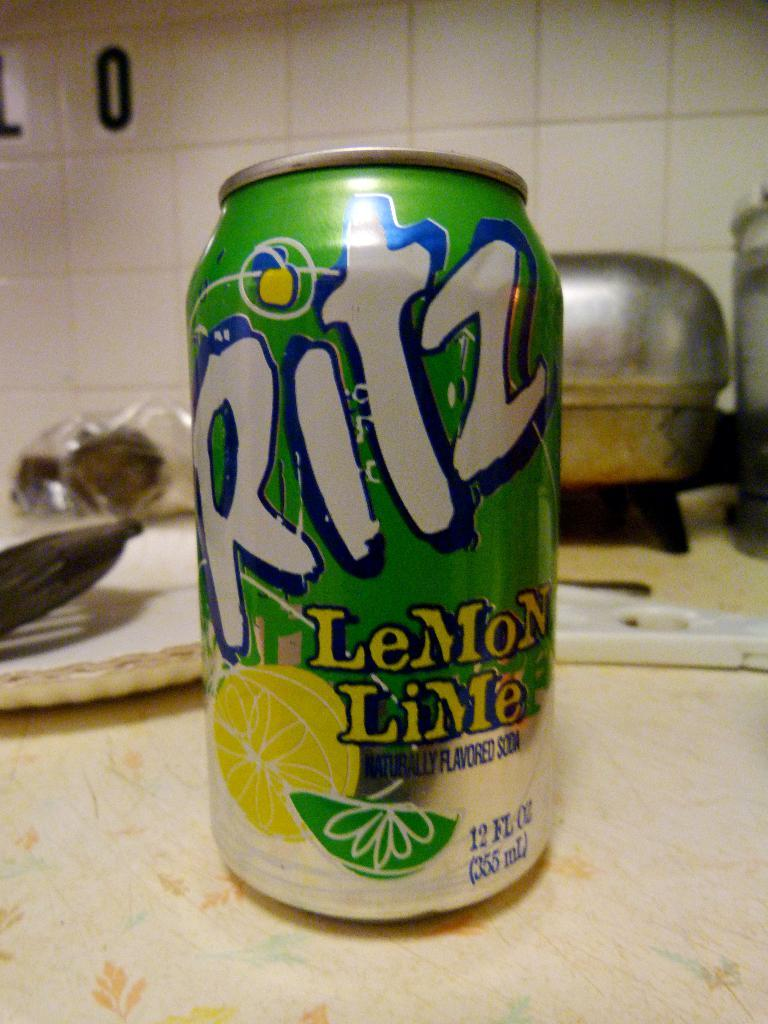<image>
Provide a brief description of the given image. a ritz can that is on a light surface 